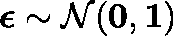<formula> <loc_0><loc_0><loc_500><loc_500>\epsilon \sim \mathcal { N } ( 0 , 1 )</formula> 